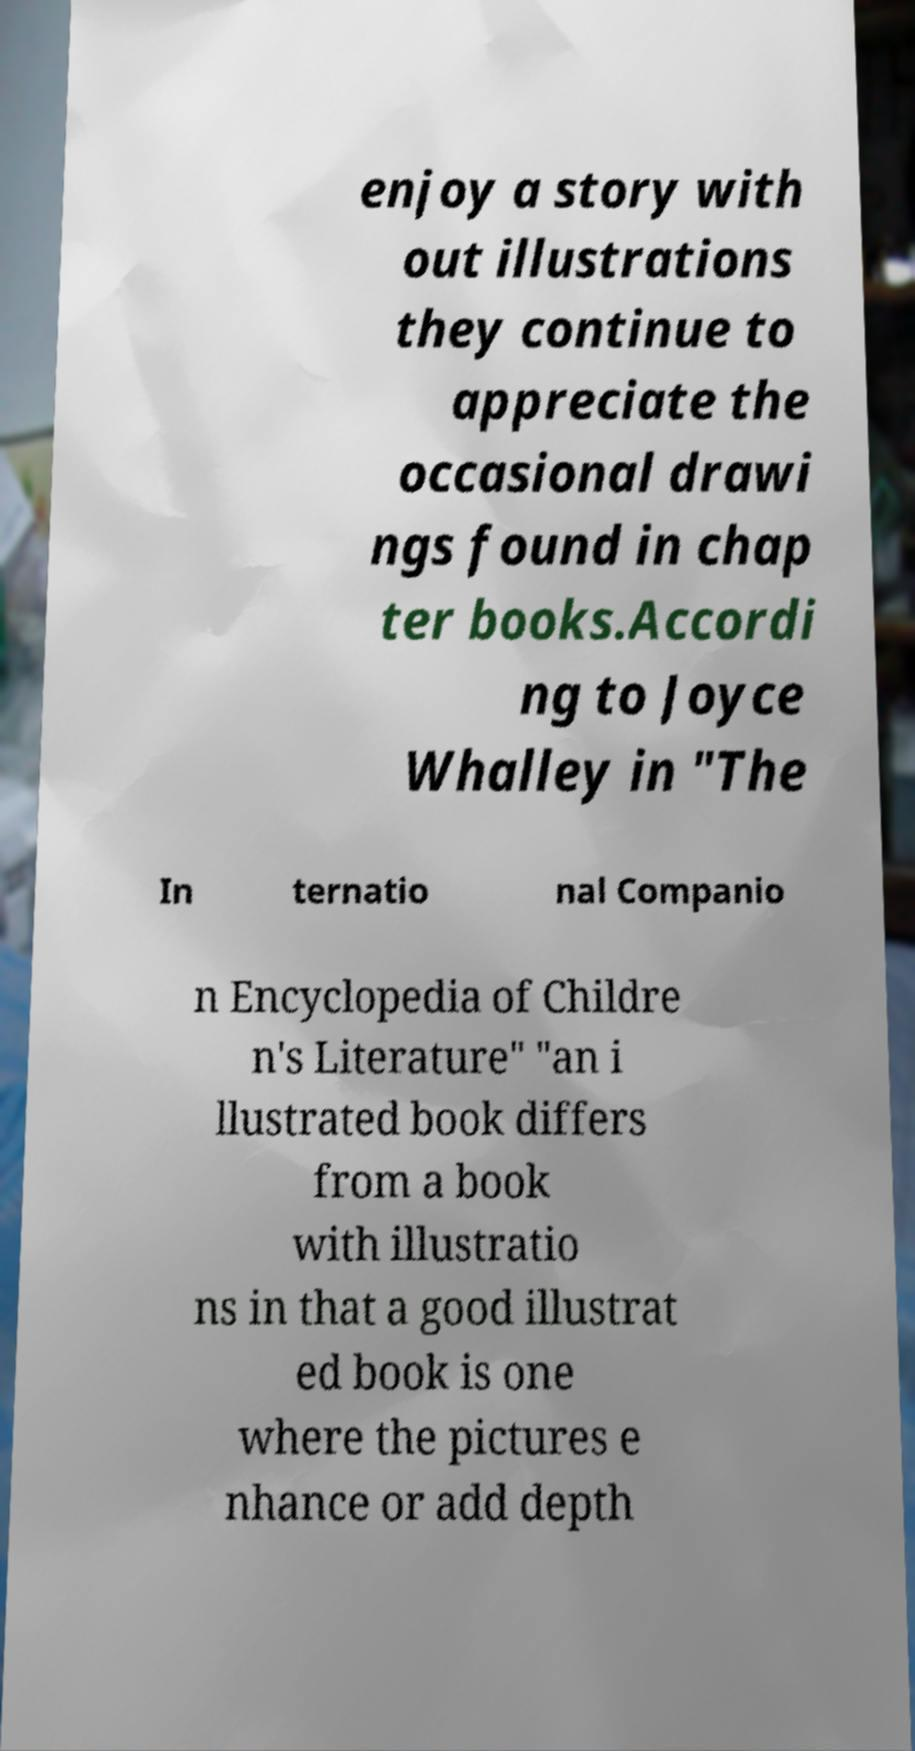Can you read and provide the text displayed in the image?This photo seems to have some interesting text. Can you extract and type it out for me? enjoy a story with out illustrations they continue to appreciate the occasional drawi ngs found in chap ter books.Accordi ng to Joyce Whalley in "The In ternatio nal Companio n Encyclopedia of Childre n's Literature" "an i llustrated book differs from a book with illustratio ns in that a good illustrat ed book is one where the pictures e nhance or add depth 